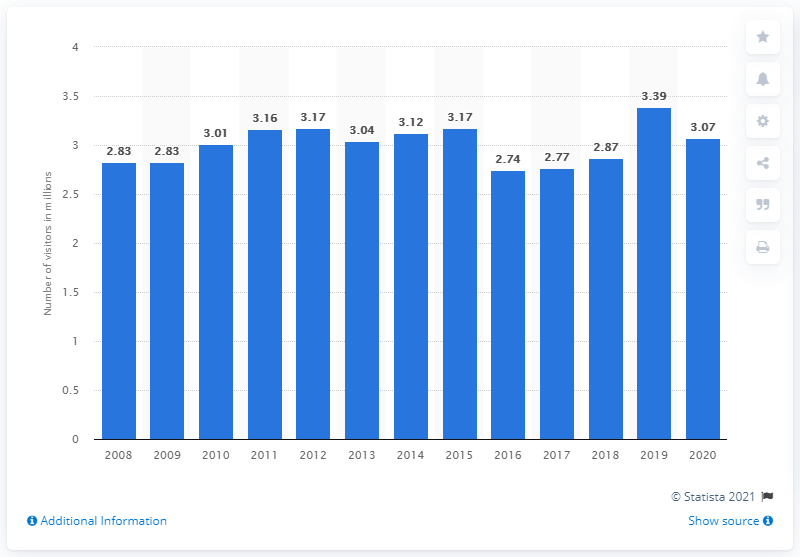Specify some key components in this picture. In 2020, the Chattahoochee River National Recreation Area was visited by approximately 3.07 million people. 